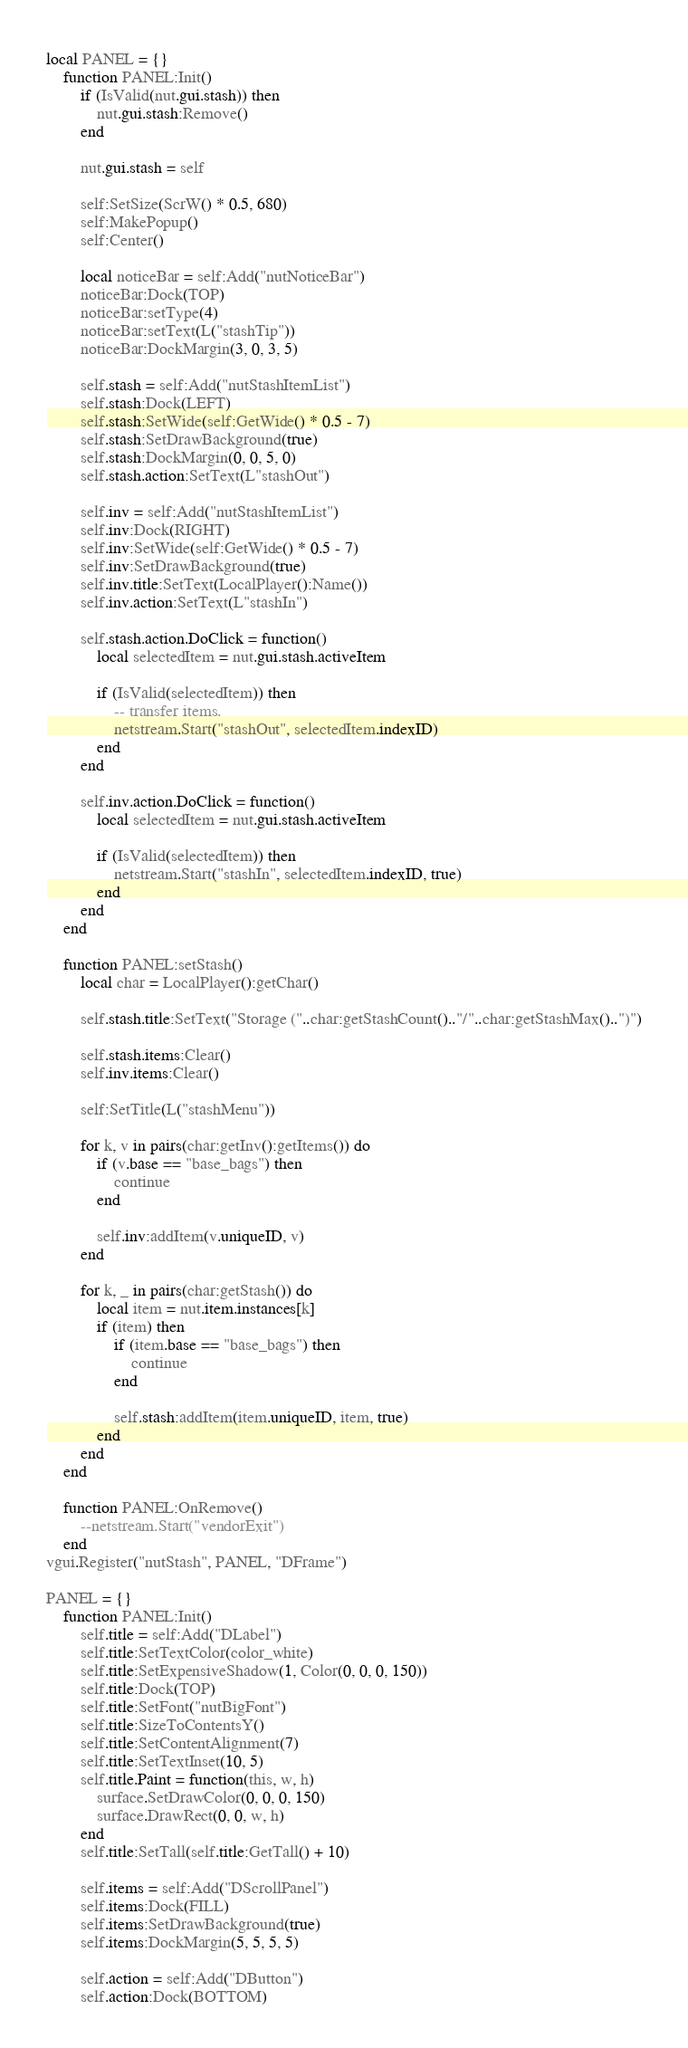Convert code to text. <code><loc_0><loc_0><loc_500><loc_500><_Lua_>local PANEL = {}
	function PANEL:Init()
		if (IsValid(nut.gui.stash)) then
			nut.gui.stash:Remove()
		end

		nut.gui.stash = self

		self:SetSize(ScrW() * 0.5, 680)
		self:MakePopup()
		self:Center()

		local noticeBar = self:Add("nutNoticeBar")
		noticeBar:Dock(TOP)
		noticeBar:setType(4)
		noticeBar:setText(L("stashTip"))
		noticeBar:DockMargin(3, 0, 3, 5)

		self.stash = self:Add("nutStashItemList")
		self.stash:Dock(LEFT)
		self.stash:SetWide(self:GetWide() * 0.5 - 7)
		self.stash:SetDrawBackground(true)
		self.stash:DockMargin(0, 0, 5, 0)
		self.stash.action:SetText(L"stashOut")

		self.inv = self:Add("nutStashItemList")
		self.inv:Dock(RIGHT)
		self.inv:SetWide(self:GetWide() * 0.5 - 7)
		self.inv:SetDrawBackground(true)
		self.inv.title:SetText(LocalPlayer():Name())
		self.inv.action:SetText(L"stashIn")

		self.stash.action.DoClick = function()
			local selectedItem = nut.gui.stash.activeItem

			if (IsValid(selectedItem)) then
				-- transfer items.
				netstream.Start("stashOut", selectedItem.indexID)
			end
		end

		self.inv.action.DoClick = function()
			local selectedItem = nut.gui.stash.activeItem

			if (IsValid(selectedItem)) then
				netstream.Start("stashIn", selectedItem.indexID, true)
			end
		end
	end

	function PANEL:setStash()
		local char = LocalPlayer():getChar()

		self.stash.title:SetText("Storage ("..char:getStashCount().."/"..char:getStashMax()..")")

		self.stash.items:Clear()
		self.inv.items:Clear()

		self:SetTitle(L("stashMenu"))

		for k, v in pairs(char:getInv():getItems()) do
			if (v.base == "base_bags") then
				continue
			end

			self.inv:addItem(v.uniqueID, v)
		end

		for k, _ in pairs(char:getStash()) do
			local item = nut.item.instances[k]
			if (item) then
				if (item.base == "base_bags") then
					continue
				end
				
				self.stash:addItem(item.uniqueID, item, true)
			end
		end
	end

	function PANEL:OnRemove()
		--netstream.Start("vendorExit")
	end
vgui.Register("nutStash", PANEL, "DFrame")

PANEL = {}
	function PANEL:Init()
		self.title = self:Add("DLabel")
		self.title:SetTextColor(color_white)
		self.title:SetExpensiveShadow(1, Color(0, 0, 0, 150))
		self.title:Dock(TOP)
		self.title:SetFont("nutBigFont")
		self.title:SizeToContentsY()
		self.title:SetContentAlignment(7)
		self.title:SetTextInset(10, 5)
		self.title.Paint = function(this, w, h)
			surface.SetDrawColor(0, 0, 0, 150)
			surface.DrawRect(0, 0, w, h)
		end
		self.title:SetTall(self.title:GetTall() + 10)

		self.items = self:Add("DScrollPanel")
		self.items:Dock(FILL)
		self.items:SetDrawBackground(true)
		self.items:DockMargin(5, 5, 5, 5)

		self.action = self:Add("DButton")
		self.action:Dock(BOTTOM)</code> 